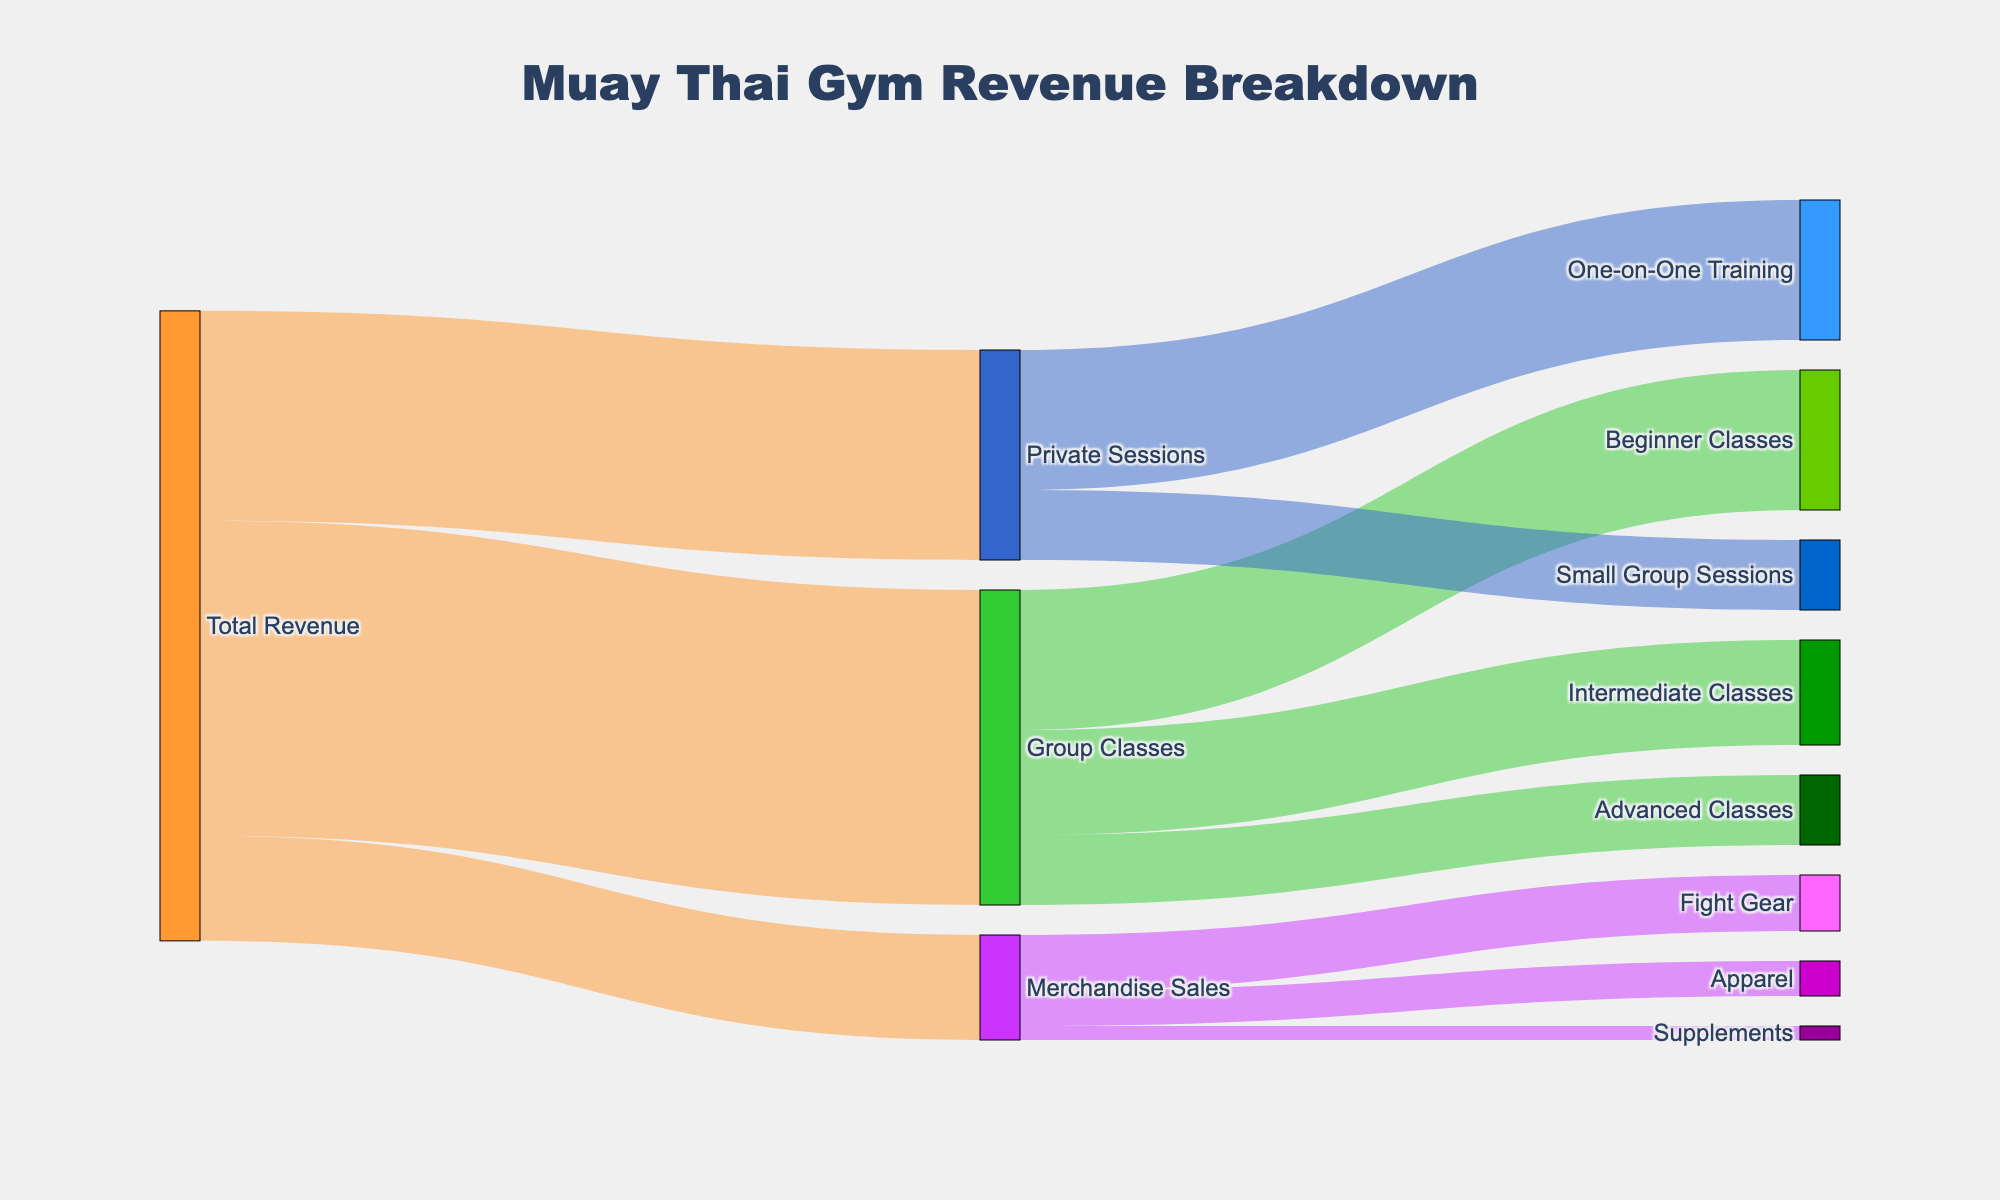What is the title of the Sankey diagram? The title of the plot is displayed prominently at the top, usually in a larger and bold font to indicate the main topic of the visualization.
Answer: Muay Thai Gym Revenue Breakdown How much revenue does Merchandise Sales generate? In the Sankey diagram, the width of each flow is proportional to its value. The figure shows that Merchandise Sales is connected to Total Revenue with a specified value of $15,000.
Answer: $15,000 Which category within Group Classes brings in the most revenue? The diagram subdivides Group Classes into three categories: Beginner Classes, Intermediate Classes, and Advanced Classes. Assess the values associated with each: Beginner Classes $20,000, Intermediate Classes $15,000, and Advanced Classes $10,000. The highest is $20,000 from Beginner Classes.
Answer: Beginner Classes What is the combined revenue of Private Sessions and Merchandise Sales? To find the total, sum the individual revenues of these categories. Private Sessions generate $30,000, and Merchandise Sales generate $15,000. Adding these gives $30,000 + $15,000 = $45,000.
Answer: $45,000 Which revenue stream is the smallest among all categories? Evaluate the smallest values among the target categories originating from Total Revenue. The values for all categories are: Beginner Classes $20,000, Intermediate Classes $15,000, Advanced Classes $10,000, One-on-One Training $20,000, Small Group Sessions $10,000, Fight Gear $8,000, Apparel $5,000, and Supplements $2,000. The smallest is Supplements with $2,000.
Answer: Supplements Between Beginner Classes and One-on-One Training, which generates more revenue and by how much? Compare the values: Beginner Classes generate $20,000, and One-on-One Training generates $20,000. The difference is $20,000 - $20,000 = $0, indicating they generate the same revenue.
Answer: They generate the same revenue What portion of the total revenue comes from Group Classes? Identify the revenue from Group Classes and relate it to Total Revenue. Group Classes generate $45,000, and Total Revenue is the sum of all categories: $45,000 (Group Classes) + $30,000 (Private Sessions) + $15,000 (Merchandise Sales) = $90,000. The portion is $45,000 / $90,000, which equates to 50%.
Answer: 50% How does the revenue from Apparel compare to that from Small Group Sessions? Analyze and compare the values. Apparel generates $5,000 while Small Group Sessions generate $10,000. $10,000 is greater than $5,000 by $5,000.
Answer: Small Group Sessions generate $5,000 more 